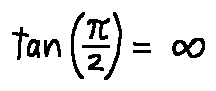Convert formula to latex. <formula><loc_0><loc_0><loc_500><loc_500>\tan ( \frac { \pi } { 2 } ) = \infty</formula> 